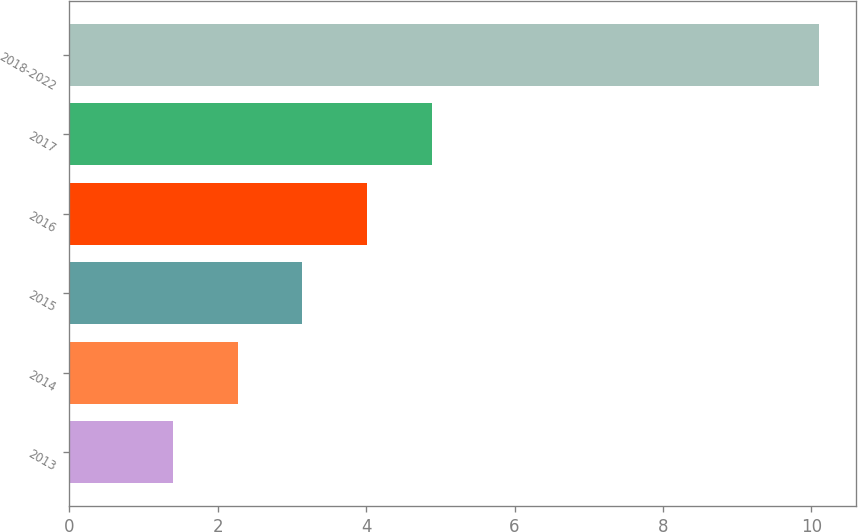Convert chart to OTSL. <chart><loc_0><loc_0><loc_500><loc_500><bar_chart><fcel>2013<fcel>2014<fcel>2015<fcel>2016<fcel>2017<fcel>2018-2022<nl><fcel>1.4<fcel>2.27<fcel>3.14<fcel>4.01<fcel>4.88<fcel>10.1<nl></chart> 